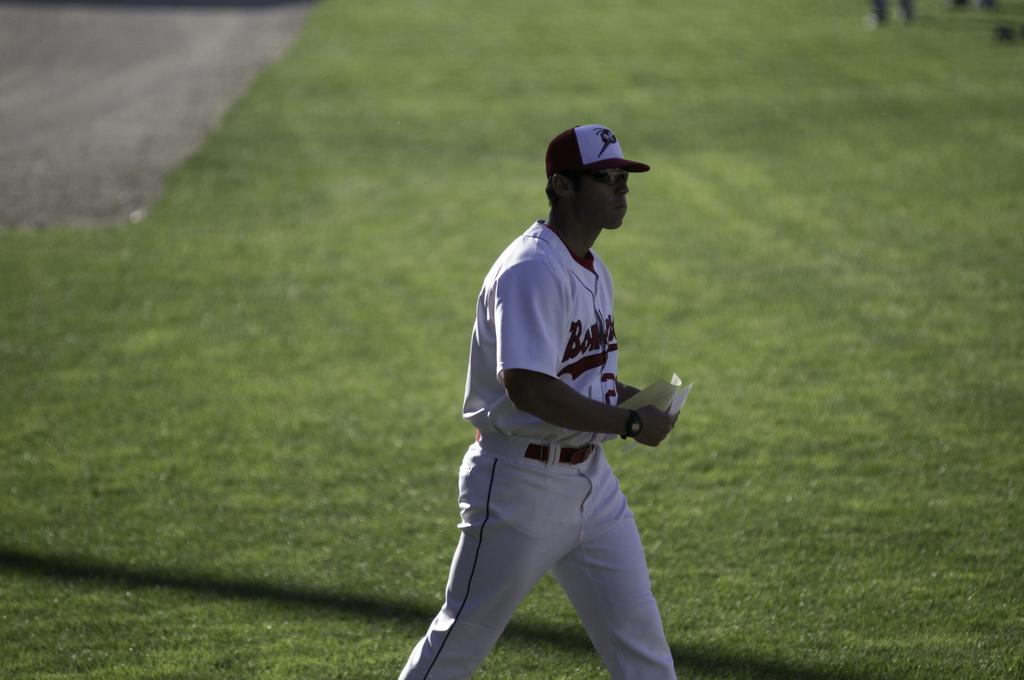What color is the text on the baseball player's shirt?
Keep it short and to the point. Red. What is the first letter on the man's shirt?
Offer a very short reply. B. 